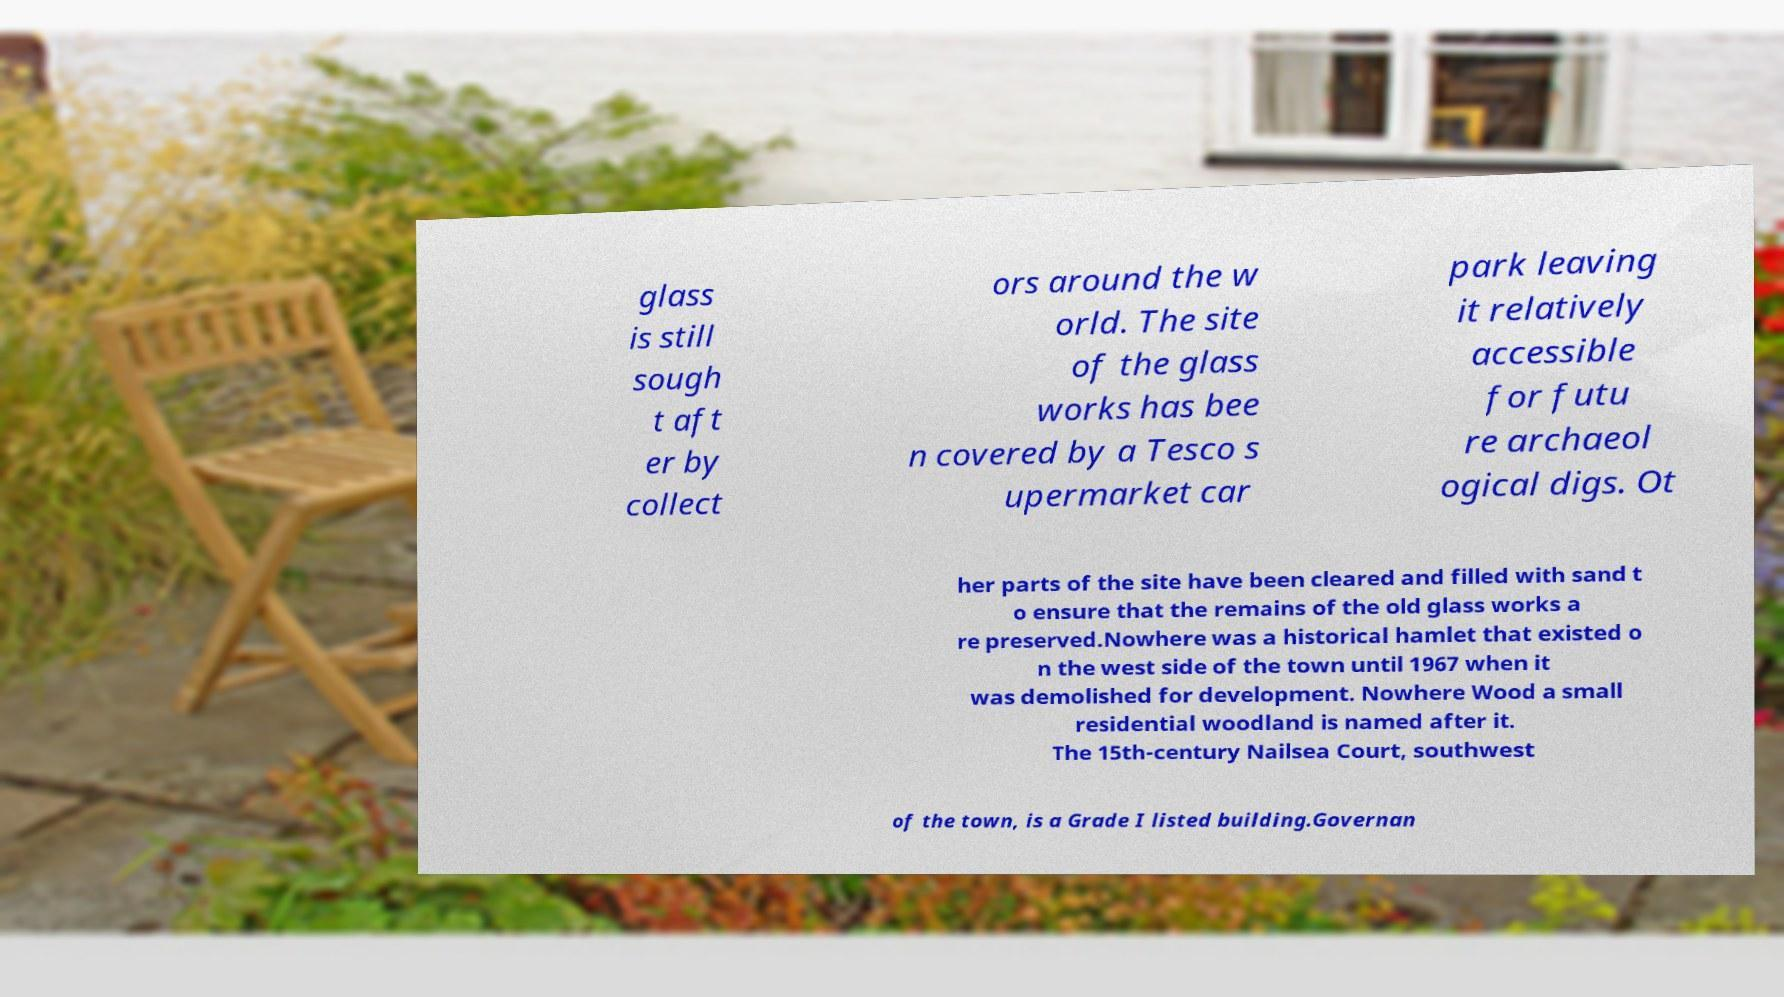I need the written content from this picture converted into text. Can you do that? glass is still sough t aft er by collect ors around the w orld. The site of the glass works has bee n covered by a Tesco s upermarket car park leaving it relatively accessible for futu re archaeol ogical digs. Ot her parts of the site have been cleared and filled with sand t o ensure that the remains of the old glass works a re preserved.Nowhere was a historical hamlet that existed o n the west side of the town until 1967 when it was demolished for development. Nowhere Wood a small residential woodland is named after it. The 15th-century Nailsea Court, southwest of the town, is a Grade I listed building.Governan 